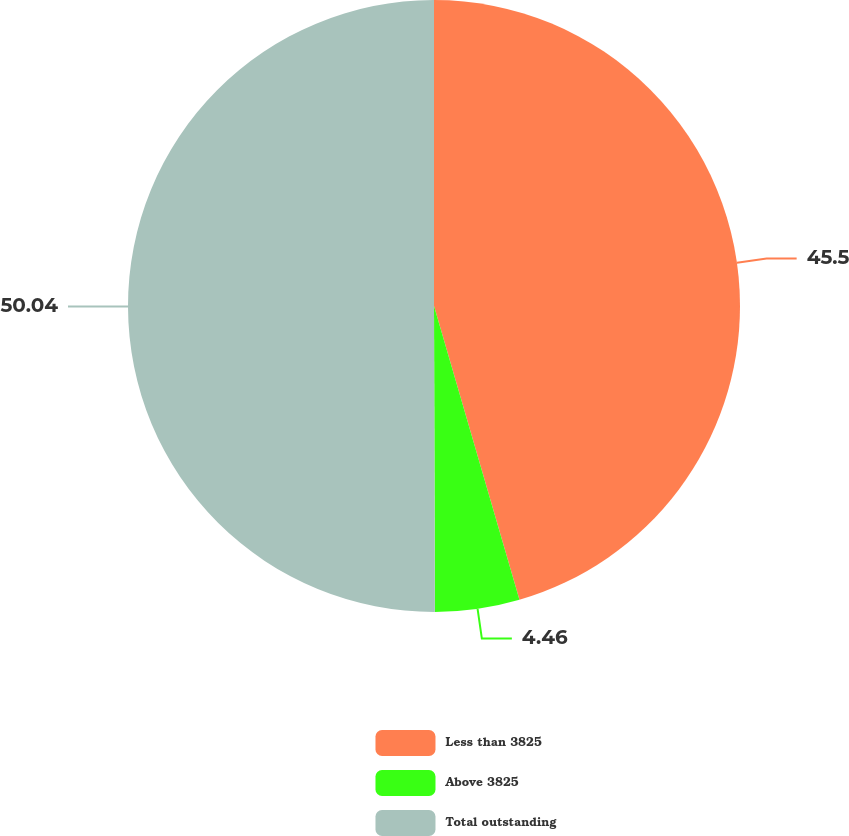Convert chart. <chart><loc_0><loc_0><loc_500><loc_500><pie_chart><fcel>Less than 3825<fcel>Above 3825<fcel>Total outstanding<nl><fcel>45.5%<fcel>4.46%<fcel>50.05%<nl></chart> 